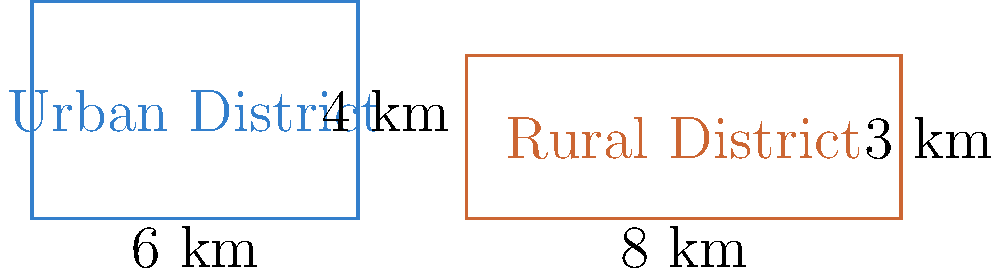In a study comparing urban and rural school districts, the areas are represented by rectangles. The urban district measures 6 km by 4 km, while the rural district measures 8 km by 3 km. What is the difference in perimeter between these two districts, and what might this difference suggest about resource allocation for boundary maintenance in urban versus rural educational settings? To solve this problem and understand its sociological implications, let's follow these steps:

1) Calculate the perimeter of the urban district:
   Urban perimeter = $2(length + width) = 2(6 + 4) = 2(10) = 20$ km

2) Calculate the perimeter of the rural district:
   Rural perimeter = $2(length + width) = 2(8 + 3) = 2(11) = 22$ km

3) Find the difference in perimeter:
   Difference = Rural perimeter - Urban perimeter = $22 - 20 = 2$ km

4) Sociological interpretation:
   The rural district has a larger perimeter despite having a smaller area. This could suggest:
   a) Rural districts might need to allocate more resources for transportation and infrastructure maintenance along their boundaries.
   b) Urban districts, while more compact, might face higher costs per kilometer due to urban density and complexity.
   c) The difference in shape (more elongated rural district) reflects different patterns of population distribution and land use in rural vs. urban areas.
   d) Policy makers might need to consider these geometric differences when allocating funds for boundary-related expenses in different types of school districts.
Answer: The rural district's perimeter is 2 km larger, suggesting potentially higher boundary-related resource needs in rural educational settings. 